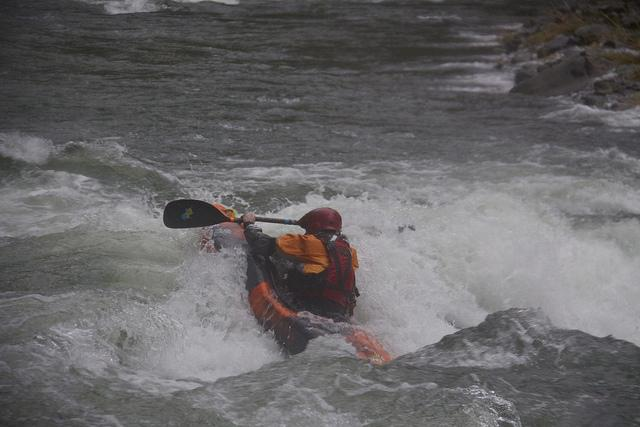What life threatening danger does this kayaker face if the waves get to high? Please explain your reasoning. drowning. The kayaker is on water. there are no fires, electrical wires, or other people near the water. 